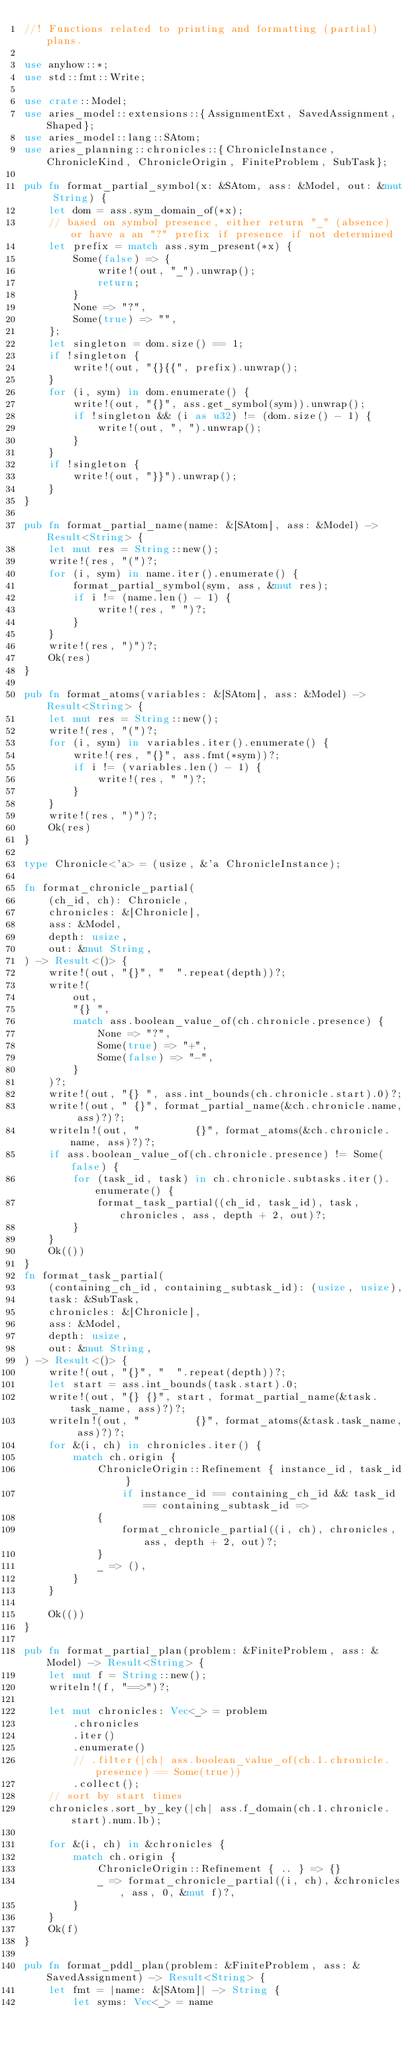<code> <loc_0><loc_0><loc_500><loc_500><_Rust_>//! Functions related to printing and formatting (partial) plans.

use anyhow::*;
use std::fmt::Write;

use crate::Model;
use aries_model::extensions::{AssignmentExt, SavedAssignment, Shaped};
use aries_model::lang::SAtom;
use aries_planning::chronicles::{ChronicleInstance, ChronicleKind, ChronicleOrigin, FiniteProblem, SubTask};

pub fn format_partial_symbol(x: &SAtom, ass: &Model, out: &mut String) {
    let dom = ass.sym_domain_of(*x);
    // based on symbol presence, either return "_" (absence) or have a an "?" prefix if presence if not determined
    let prefix = match ass.sym_present(*x) {
        Some(false) => {
            write!(out, "_").unwrap();
            return;
        }
        None => "?",
        Some(true) => "",
    };
    let singleton = dom.size() == 1;
    if !singleton {
        write!(out, "{}{{", prefix).unwrap();
    }
    for (i, sym) in dom.enumerate() {
        write!(out, "{}", ass.get_symbol(sym)).unwrap();
        if !singleton && (i as u32) != (dom.size() - 1) {
            write!(out, ", ").unwrap();
        }
    }
    if !singleton {
        write!(out, "}}").unwrap();
    }
}

pub fn format_partial_name(name: &[SAtom], ass: &Model) -> Result<String> {
    let mut res = String::new();
    write!(res, "(")?;
    for (i, sym) in name.iter().enumerate() {
        format_partial_symbol(sym, ass, &mut res);
        if i != (name.len() - 1) {
            write!(res, " ")?;
        }
    }
    write!(res, ")")?;
    Ok(res)
}

pub fn format_atoms(variables: &[SAtom], ass: &Model) -> Result<String> {
    let mut res = String::new();
    write!(res, "(")?;
    for (i, sym) in variables.iter().enumerate() {
        write!(res, "{}", ass.fmt(*sym))?;
        if i != (variables.len() - 1) {
            write!(res, " ")?;
        }
    }
    write!(res, ")")?;
    Ok(res)
}

type Chronicle<'a> = (usize, &'a ChronicleInstance);

fn format_chronicle_partial(
    (ch_id, ch): Chronicle,
    chronicles: &[Chronicle],
    ass: &Model,
    depth: usize,
    out: &mut String,
) -> Result<()> {
    write!(out, "{}", "  ".repeat(depth))?;
    write!(
        out,
        "{} ",
        match ass.boolean_value_of(ch.chronicle.presence) {
            None => "?",
            Some(true) => "+",
            Some(false) => "-",
        }
    )?;
    write!(out, "{} ", ass.int_bounds(ch.chronicle.start).0)?;
    write!(out, " {}", format_partial_name(&ch.chronicle.name, ass)?)?;
    writeln!(out, "         {}", format_atoms(&ch.chronicle.name, ass)?)?;
    if ass.boolean_value_of(ch.chronicle.presence) != Some(false) {
        for (task_id, task) in ch.chronicle.subtasks.iter().enumerate() {
            format_task_partial((ch_id, task_id), task, chronicles, ass, depth + 2, out)?;
        }
    }
    Ok(())
}
fn format_task_partial(
    (containing_ch_id, containing_subtask_id): (usize, usize),
    task: &SubTask,
    chronicles: &[Chronicle],
    ass: &Model,
    depth: usize,
    out: &mut String,
) -> Result<()> {
    write!(out, "{}", "  ".repeat(depth))?;
    let start = ass.int_bounds(task.start).0;
    write!(out, "{} {}", start, format_partial_name(&task.task_name, ass)?)?;
    writeln!(out, "         {}", format_atoms(&task.task_name, ass)?)?;
    for &(i, ch) in chronicles.iter() {
        match ch.origin {
            ChronicleOrigin::Refinement { instance_id, task_id }
                if instance_id == containing_ch_id && task_id == containing_subtask_id =>
            {
                format_chronicle_partial((i, ch), chronicles, ass, depth + 2, out)?;
            }
            _ => (),
        }
    }

    Ok(())
}

pub fn format_partial_plan(problem: &FiniteProblem, ass: &Model) -> Result<String> {
    let mut f = String::new();
    writeln!(f, "==>")?;

    let mut chronicles: Vec<_> = problem
        .chronicles
        .iter()
        .enumerate()
        // .filter(|ch| ass.boolean_value_of(ch.1.chronicle.presence) == Some(true))
        .collect();
    // sort by start times
    chronicles.sort_by_key(|ch| ass.f_domain(ch.1.chronicle.start).num.lb);

    for &(i, ch) in &chronicles {
        match ch.origin {
            ChronicleOrigin::Refinement { .. } => {}
            _ => format_chronicle_partial((i, ch), &chronicles, ass, 0, &mut f)?,
        }
    }
    Ok(f)
}

pub fn format_pddl_plan(problem: &FiniteProblem, ass: &SavedAssignment) -> Result<String> {
    let fmt = |name: &[SAtom]| -> String {
        let syms: Vec<_> = name</code> 